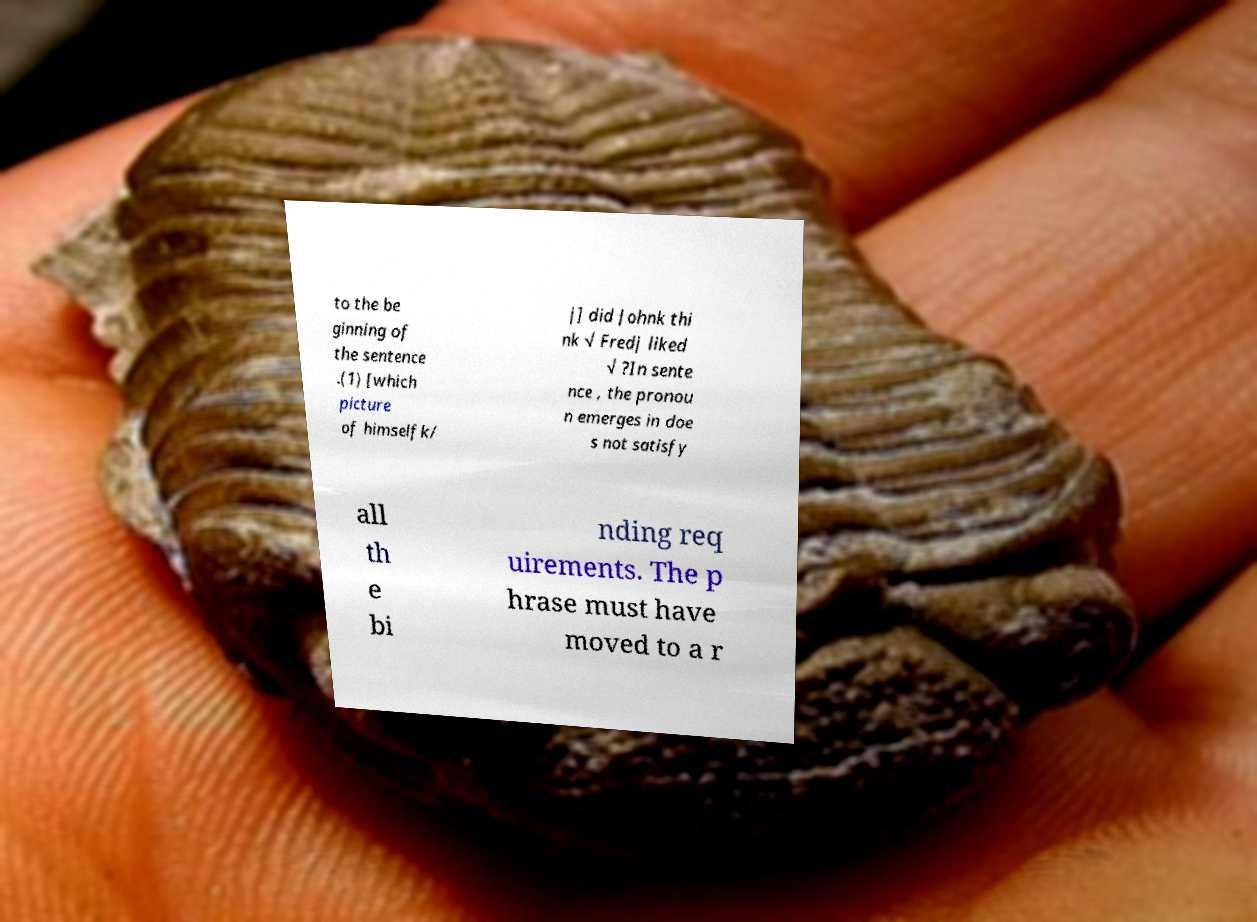Can you read and provide the text displayed in the image?This photo seems to have some interesting text. Can you extract and type it out for me? to the be ginning of the sentence .(1) [which picture of himselfk/ j] did Johnk thi nk √ Fredj liked √ ?In sente nce , the pronou n emerges in doe s not satisfy all th e bi nding req uirements. The p hrase must have moved to a r 